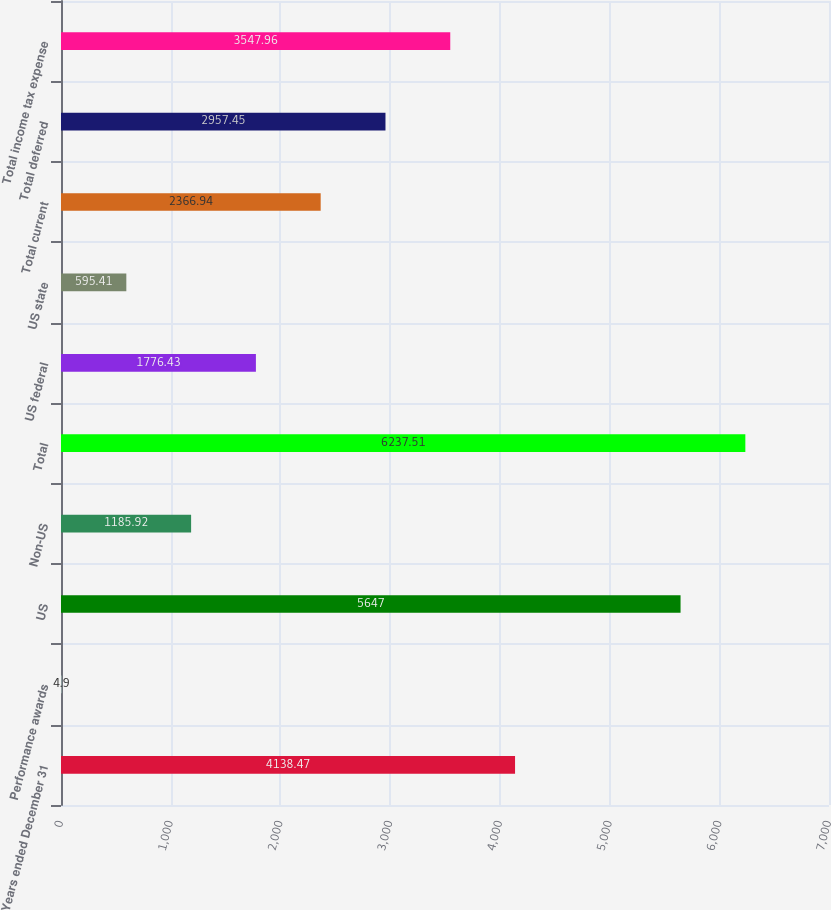Convert chart. <chart><loc_0><loc_0><loc_500><loc_500><bar_chart><fcel>Years ended December 31<fcel>Performance awards<fcel>US<fcel>Non-US<fcel>Total<fcel>US federal<fcel>US state<fcel>Total current<fcel>Total deferred<fcel>Total income tax expense<nl><fcel>4138.47<fcel>4.9<fcel>5647<fcel>1185.92<fcel>6237.51<fcel>1776.43<fcel>595.41<fcel>2366.94<fcel>2957.45<fcel>3547.96<nl></chart> 